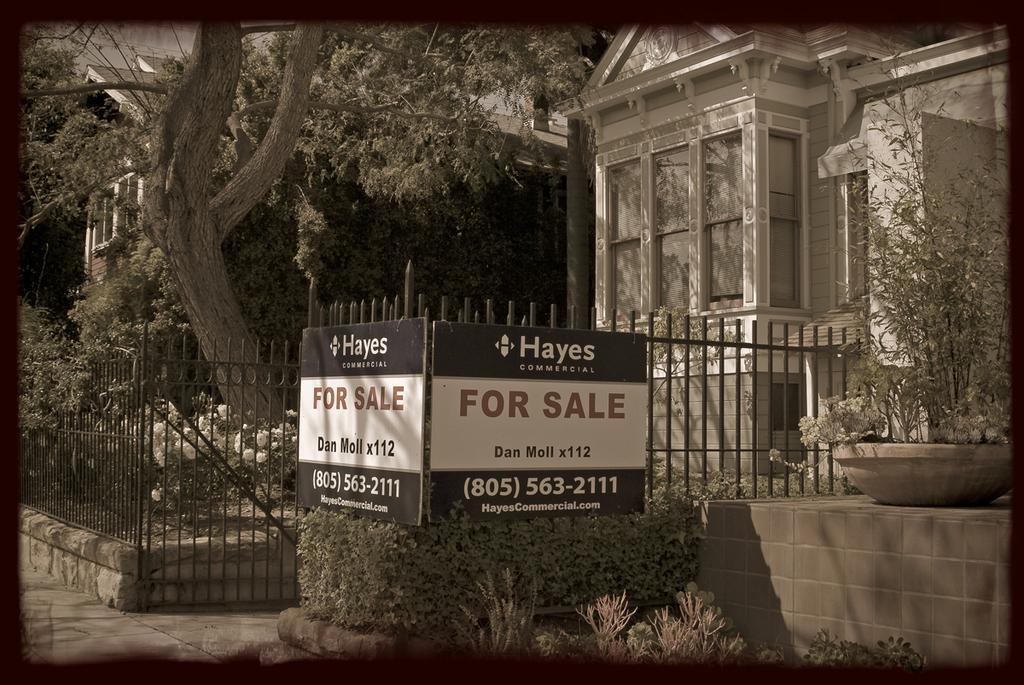In one or two sentences, can you explain what this image depicts? In this image I can see boards, houseplants, fence, buildings and trees. This image looks like a photo frame. 